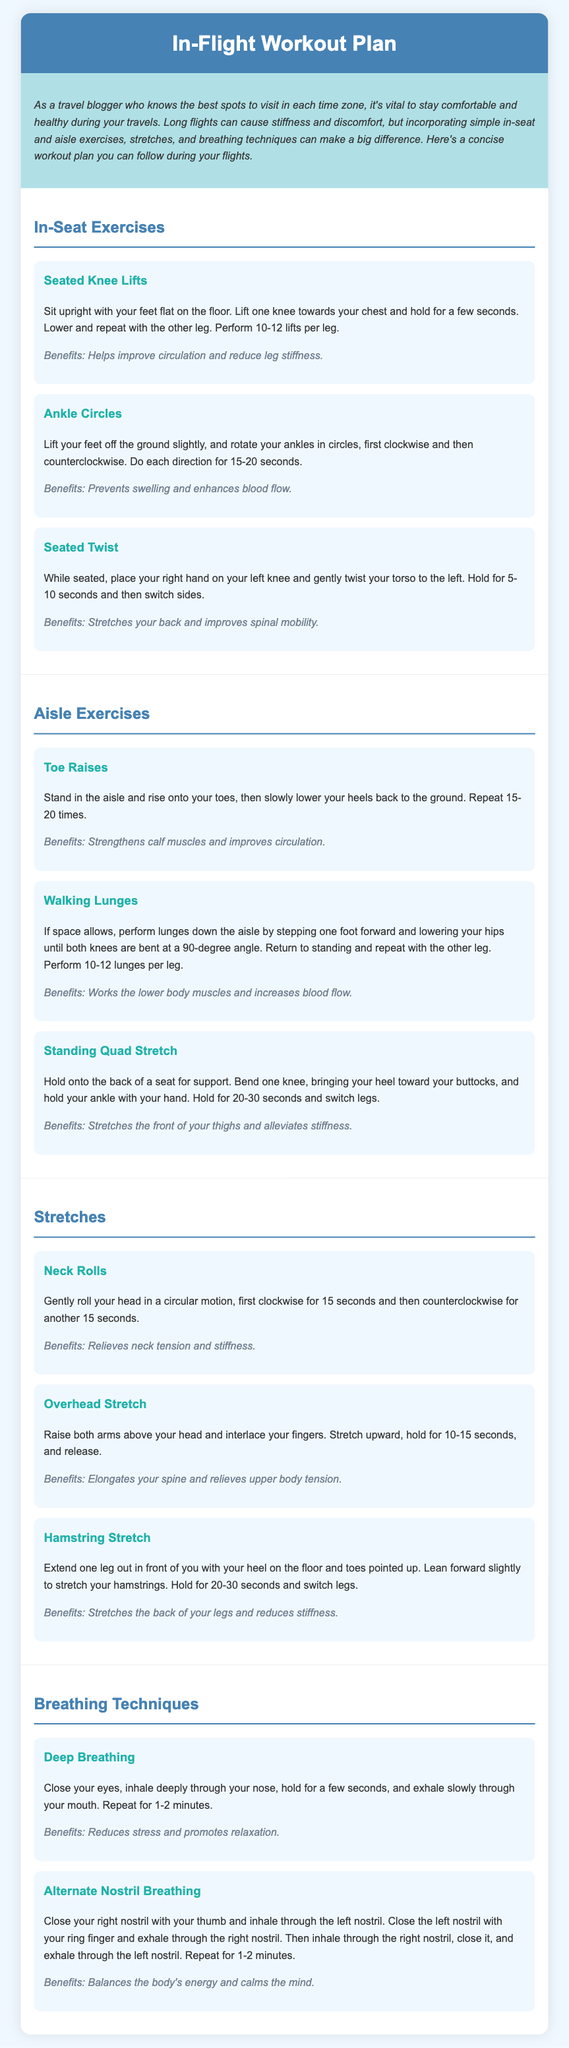what is the title of the document? The title is found in the header section of the document.
Answer: In-Flight Workout Plan how many in-seat exercises are listed? The number of in-seat exercises is mentioned in the corresponding section of the document.
Answer: Three what is one benefit of Seated Knee Lifts? The benefits are provided below each exercise description.
Answer: Helps improve circulation and reduce leg stiffness how long should you hold the Standing Quad Stretch? The document specifies the duration for each exercise or stretch.
Answer: 20-30 seconds which breathing technique helps reduce stress? The techniques section lists various breathing techniques and their benefits.
Answer: Deep Breathing what is the purpose of the Overhead Stretch? The purpose is described alongside the benefits of each stretch in the document.
Answer: Elongates your spine and relieves upper body tension how many repetitions should you perform for Toe Raises? The recommendation for repetitions is included in the exercise description.
Answer: 15-20 times what motion do you make during Neck Rolls? The movement type is described in the instructions for the stretch.
Answer: Circular motion what is one benefit of Alternate Nostril Breathing? The benefits are outlined following each technique description.
Answer: Balances the body's energy and calms the mind 